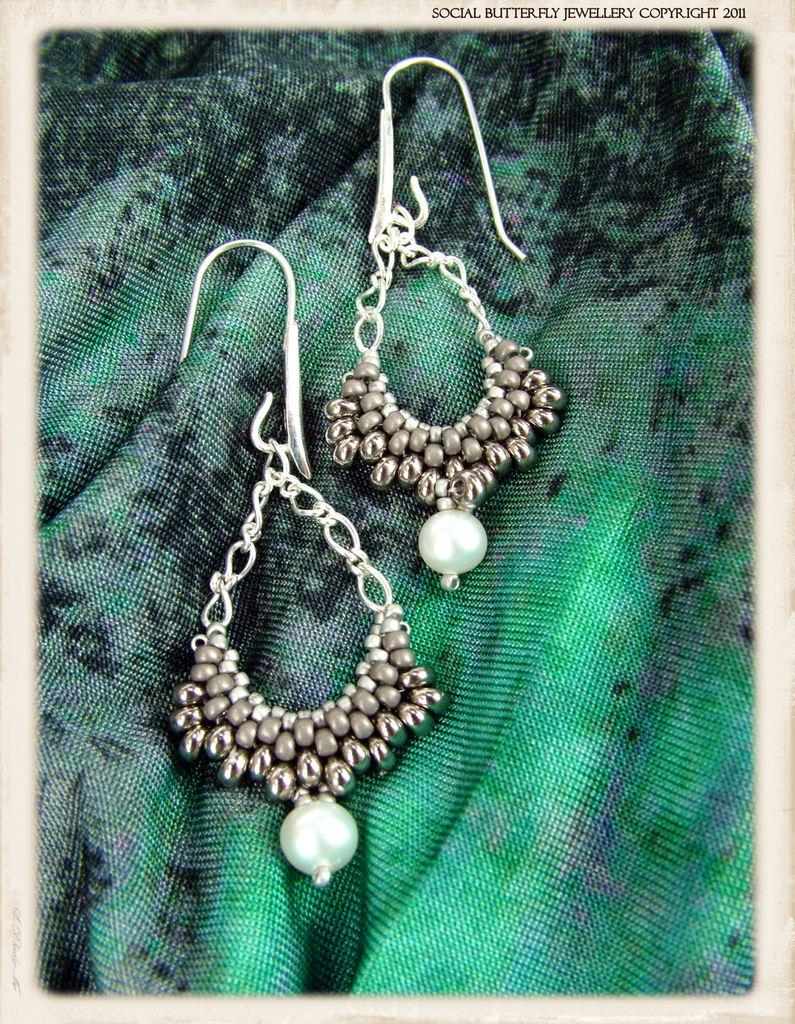What type of accessory is in the image? There is a pair of earrings in the image. Where are the earrings placed in the image? The earrings are on a cloth. How many waves can be seen crashing on the shore in the image? There are no waves or shore visible in the image; it features a pair of earrings on a cloth. 